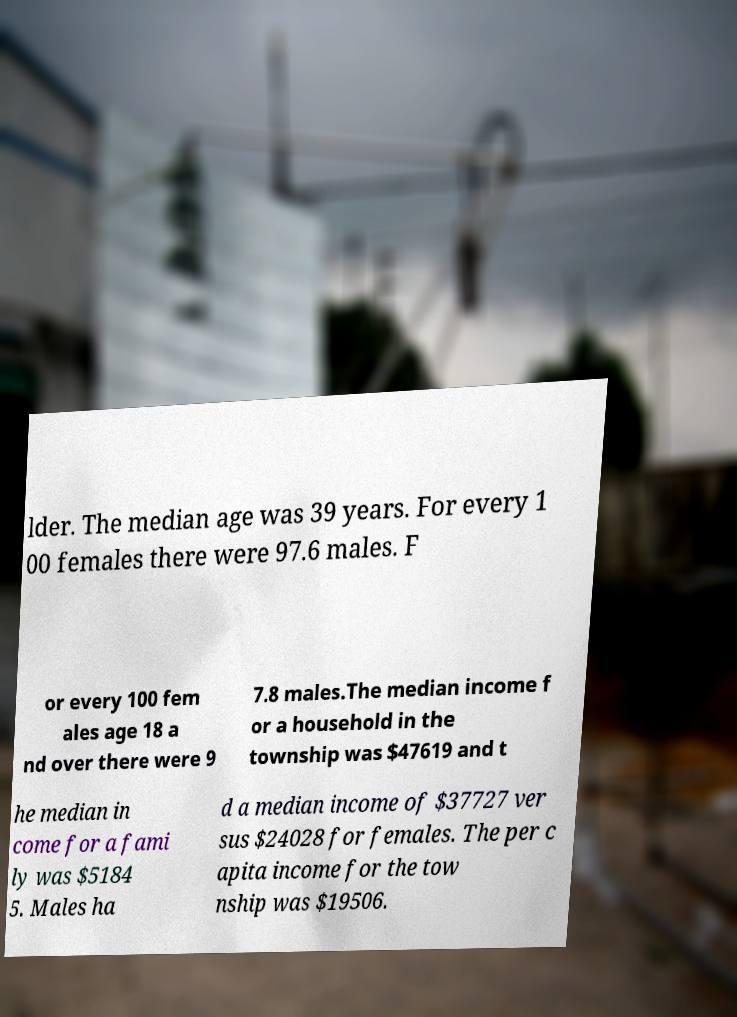Please identify and transcribe the text found in this image. lder. The median age was 39 years. For every 1 00 females there were 97.6 males. F or every 100 fem ales age 18 a nd over there were 9 7.8 males.The median income f or a household in the township was $47619 and t he median in come for a fami ly was $5184 5. Males ha d a median income of $37727 ver sus $24028 for females. The per c apita income for the tow nship was $19506. 